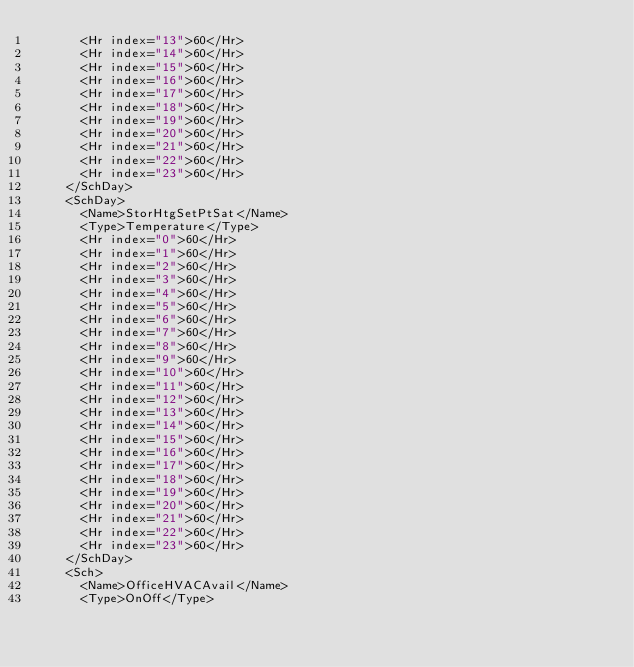Convert code to text. <code><loc_0><loc_0><loc_500><loc_500><_XML_>      <Hr index="13">60</Hr>
      <Hr index="14">60</Hr>
      <Hr index="15">60</Hr>
      <Hr index="16">60</Hr>
      <Hr index="17">60</Hr>
      <Hr index="18">60</Hr>
      <Hr index="19">60</Hr>
      <Hr index="20">60</Hr>
      <Hr index="21">60</Hr>
      <Hr index="22">60</Hr>
      <Hr index="23">60</Hr>
    </SchDay>
    <SchDay>
      <Name>StorHtgSetPtSat</Name>
      <Type>Temperature</Type>
      <Hr index="0">60</Hr>
      <Hr index="1">60</Hr>
      <Hr index="2">60</Hr>
      <Hr index="3">60</Hr>
      <Hr index="4">60</Hr>
      <Hr index="5">60</Hr>
      <Hr index="6">60</Hr>
      <Hr index="7">60</Hr>
      <Hr index="8">60</Hr>
      <Hr index="9">60</Hr>
      <Hr index="10">60</Hr>
      <Hr index="11">60</Hr>
      <Hr index="12">60</Hr>
      <Hr index="13">60</Hr>
      <Hr index="14">60</Hr>
      <Hr index="15">60</Hr>
      <Hr index="16">60</Hr>
      <Hr index="17">60</Hr>
      <Hr index="18">60</Hr>
      <Hr index="19">60</Hr>
      <Hr index="20">60</Hr>
      <Hr index="21">60</Hr>
      <Hr index="22">60</Hr>
      <Hr index="23">60</Hr>
    </SchDay>
    <Sch>
      <Name>OfficeHVACAvail</Name>
      <Type>OnOff</Type></code> 